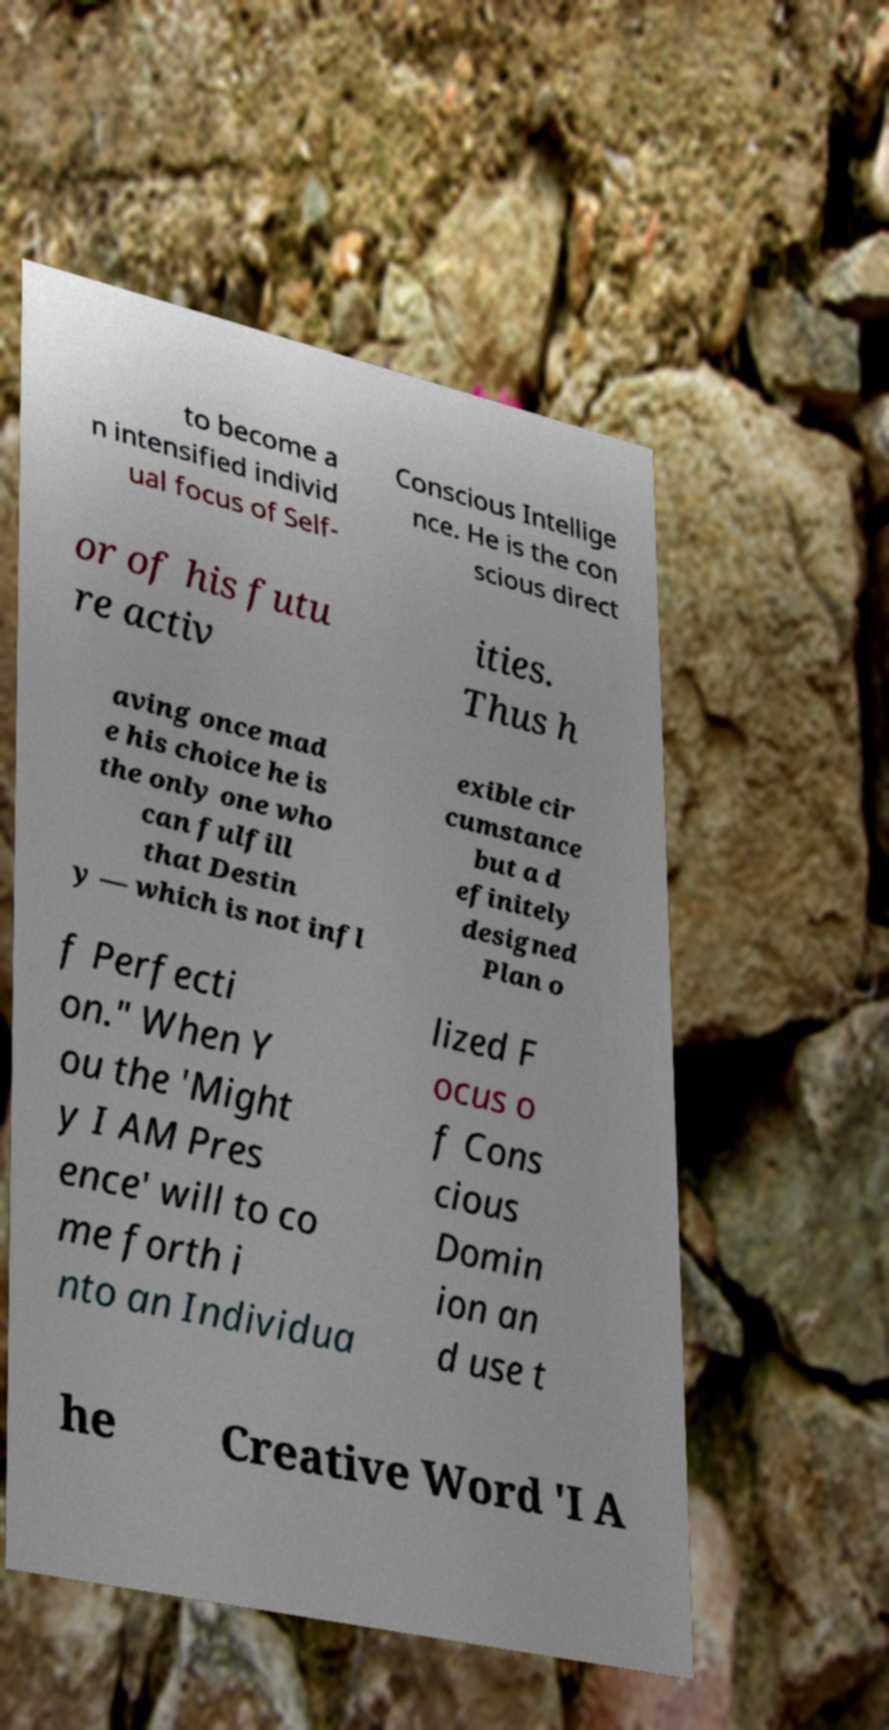There's text embedded in this image that I need extracted. Can you transcribe it verbatim? to become a n intensified individ ual focus of Self- Conscious Intellige nce. He is the con scious direct or of his futu re activ ities. Thus h aving once mad e his choice he is the only one who can fulfill that Destin y — which is not infl exible cir cumstance but a d efinitely designed Plan o f Perfecti on." When Y ou the 'Might y I AM Pres ence' will to co me forth i nto an Individua lized F ocus o f Cons cious Domin ion an d use t he Creative Word 'I A 